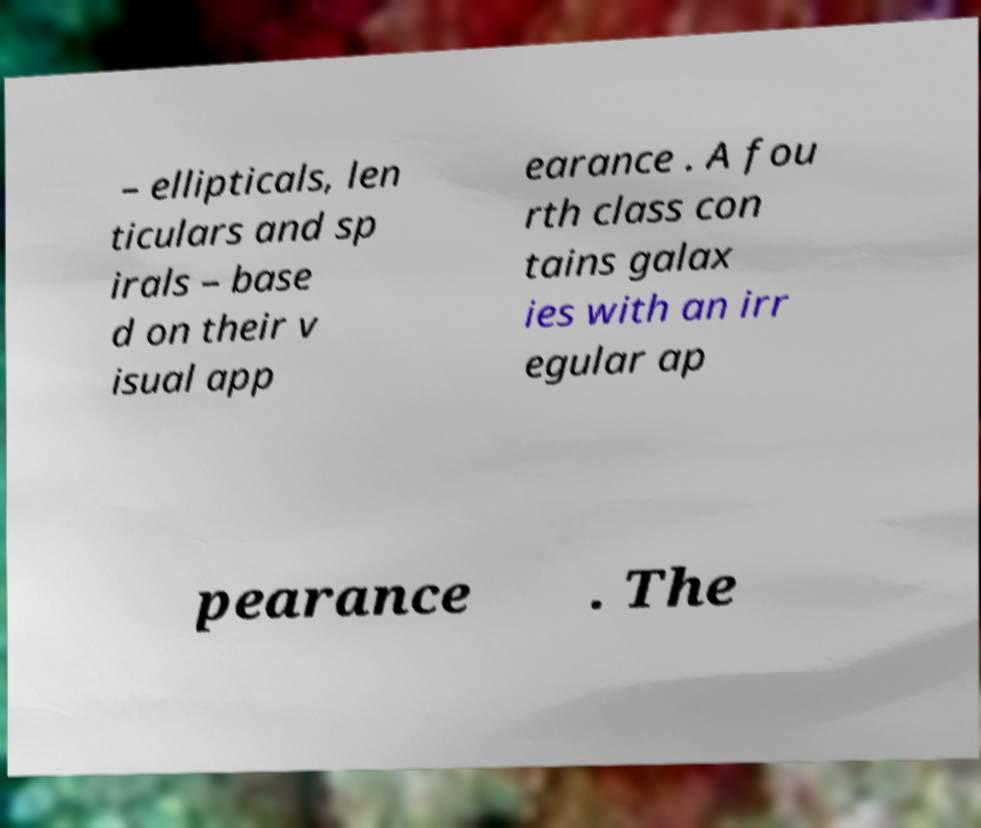What messages or text are displayed in this image? I need them in a readable, typed format. – ellipticals, len ticulars and sp irals – base d on their v isual app earance . A fou rth class con tains galax ies with an irr egular ap pearance . The 